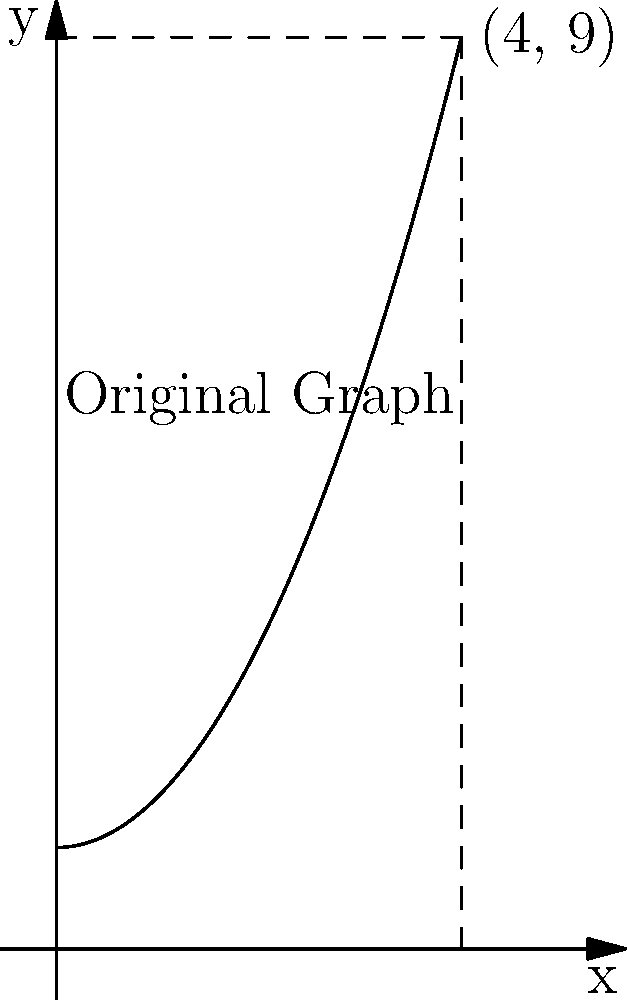The graph above represents the financial growth of Access Point Financial over the past 4 years, with the x-axis representing time and the y-axis representing profits in millions. If this graph is rotated 90 degrees counterclockwise around the origin, what will be the new coordinates of the point (4, 9)? To solve this problem, we need to understand how rotation affects coordinates:

1. A 90-degree counterclockwise rotation transforms coordinates (x, y) to (-y, x).

2. The original point is (4, 9).

3. Applying the rotation:
   - The x-coordinate becomes the negative of the original y: -9
   - The y-coordinate becomes the original x: 4

4. Therefore, after rotation, the point (4, 9) becomes (-9, 4).

This transformation effectively switches the axes, with the profit axis now becoming horizontal and the time axis becoming vertical, but in the negative direction. This new perspective could provide insights into how rapidly profits are increasing over time.
Answer: (-9, 4) 